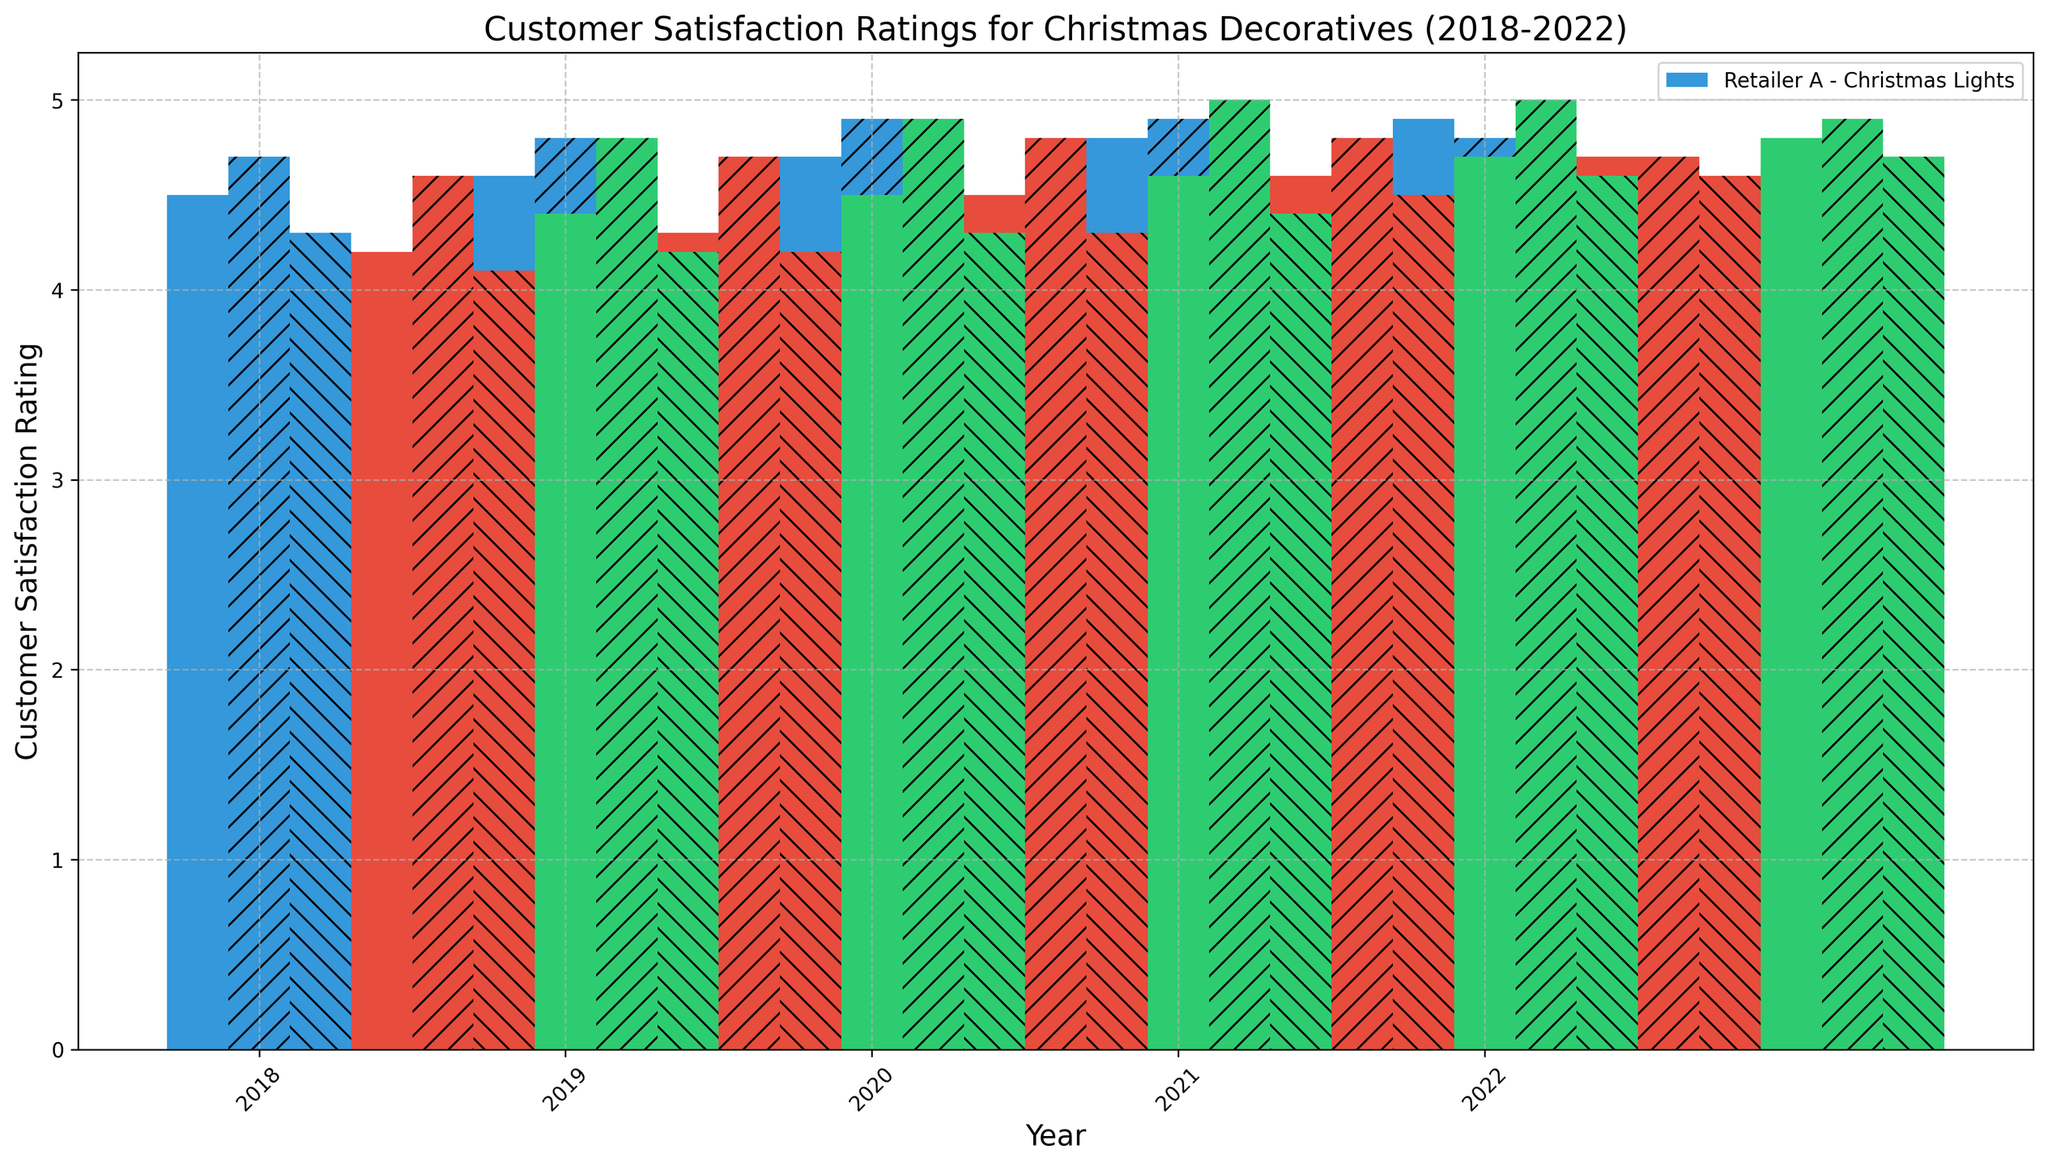Which retailer had the highest customer satisfaction rating for Christmas Trees in 2020? Look at the bars corresponding to Christmas Trees for all retailers in 2020. Retailer C has the tallest bar.
Answer: Retailer C How did Retailer B's customer satisfaction ratings for Christmas Lights change from 2018 to 2022? Compare the heights of the bars for Retailer B's Christmas Lights from 2018 to 2022. The rating increased from 4.2 in 2018 to 4.7 in 2022.
Answer: It increased Which product had the highest average customer satisfaction rating across all years and retailers? Calculate the average rating for each product by summing the ratings and dividing by the number of data points. Summing the ratings of Christmas Trees: 4.7 + 4.6 + 4.8 + 4.8 + 4.9 + 4.7 + 4.9 + 4.8 + 4.9 + 5.0 + 4.8 + 4.8 + 4.9 = 48.8, divided by 15 is approximately 4.87. Ornaments: 4.3 + 4.1 + 4.2 + 4.4 + 4.2 + 4.3 + 4.5 + 4.3 + 4.4 + 4.6 + 4.5 + 4.6 + 4.7 + 4.6 + 4.7 = 64.6, divided by 15 is approximately 4.31. Christmas Lights: 4.5 + 4.2 + 4.4 + 4.6 + 4.3 + 4.5 + 4.7 + 4.5 + 4.6 + 4.8 + 4.6 + 4.7 + 4.9 + 4.7 + 4.8 = 67.2, divided by 15 is approximately 4.48. Therefore, Christmas Trees had the highest average rating with approximately 4.87.
Answer: Christmas Trees In which year did Retailer A receive the highest customer satisfaction rating for Ornaments? Look at the bars corresponding to Retailer A's Ornaments from 2018 to 2022 and find the highest. In 2022, the bar is tallest with a rating of 4.7.
Answer: 2022 Did any retailer receive a perfect customer satisfaction rating for any product in any year? Look for any bars reaching the maximum rating of 5.0. Retailer C received a 5.0 rating for Christmas Trees in 2020 and 2021.
Answer: Yes Which year's customer satisfaction rating for Christmas Lights was the lowest across all retailers? Identify the bar with the lowest height for Christmas Lights across all years and retailers. In 2018, Retailer B had the lowest with a rating of 4.2.
Answer: 2018 Compare the customer satisfaction ratings for Christmas Trees between Retailer A and Retailer C in 2019. Look at the bars for Christmas Trees for both retailers in 2019. Retailer A's rating is 4.8, while Retailer C's rating is 4.9.
Answer: Retailer C had a higher rating How did customer satisfaction ratings for Ornaments change over the years for Retailer C? Examine the bars for Ornaments for Retailer C from 2018 to 2022. The ratings increased from 4.2 in 2018 to 4.7 in 2022, with a generally upward trend.
Answer: Increased overall Which retailer saw the most consistent customer satisfaction ratings for Christmas Lights from 2018-2022? Compare the bars for Christmas Lights across all retailers from 2018 to 2022. Retailer C has no significant drastic ups and downs and remains in a narrow range from 4.4 to 4.8.
Answer: Retailer C What was the average customer satisfaction rating for all products for Retailer B in 2021? Add the ratings of all products for Retailer B in 2021 (4.6 + 4.8 + 4.5) and divide by 3. (4.6 + 4.8 + 4.5) = 13.9, then 13.9 / 3 = 4.63
Answer: 4.63 